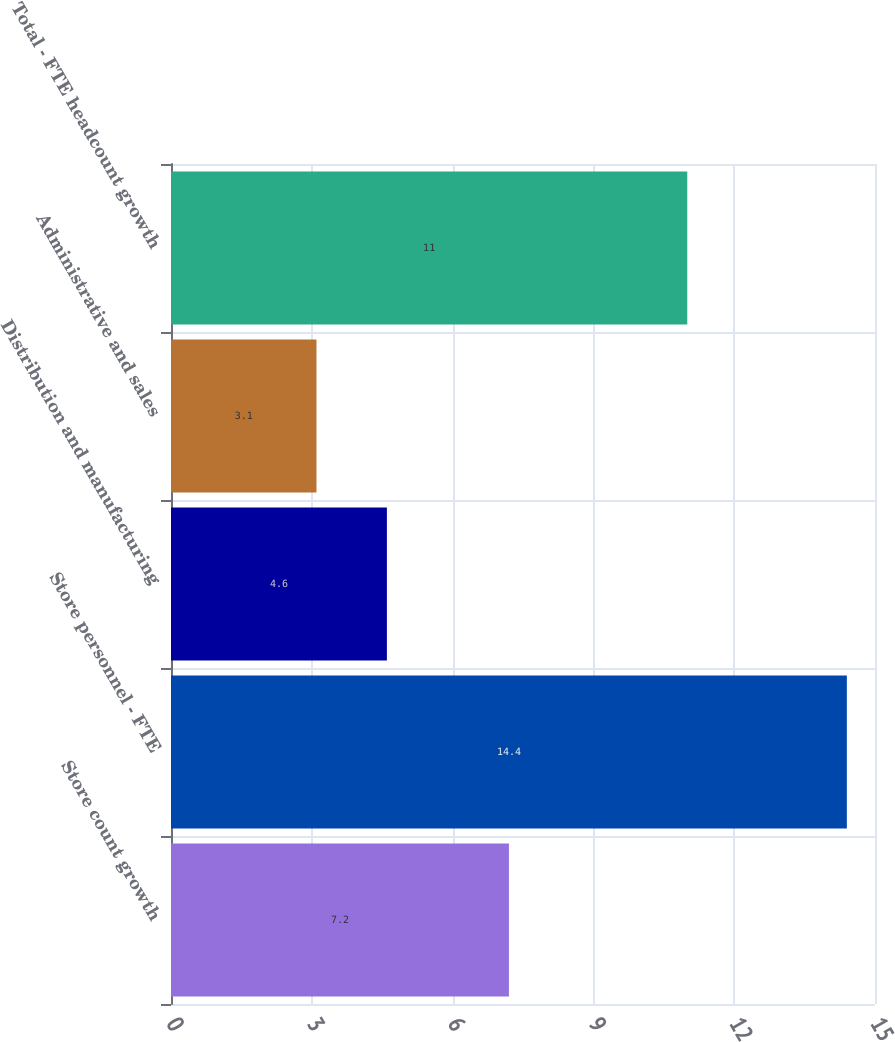<chart> <loc_0><loc_0><loc_500><loc_500><bar_chart><fcel>Store count growth<fcel>Store personnel - FTE<fcel>Distribution and manufacturing<fcel>Administrative and sales<fcel>Total - FTE headcount growth<nl><fcel>7.2<fcel>14.4<fcel>4.6<fcel>3.1<fcel>11<nl></chart> 